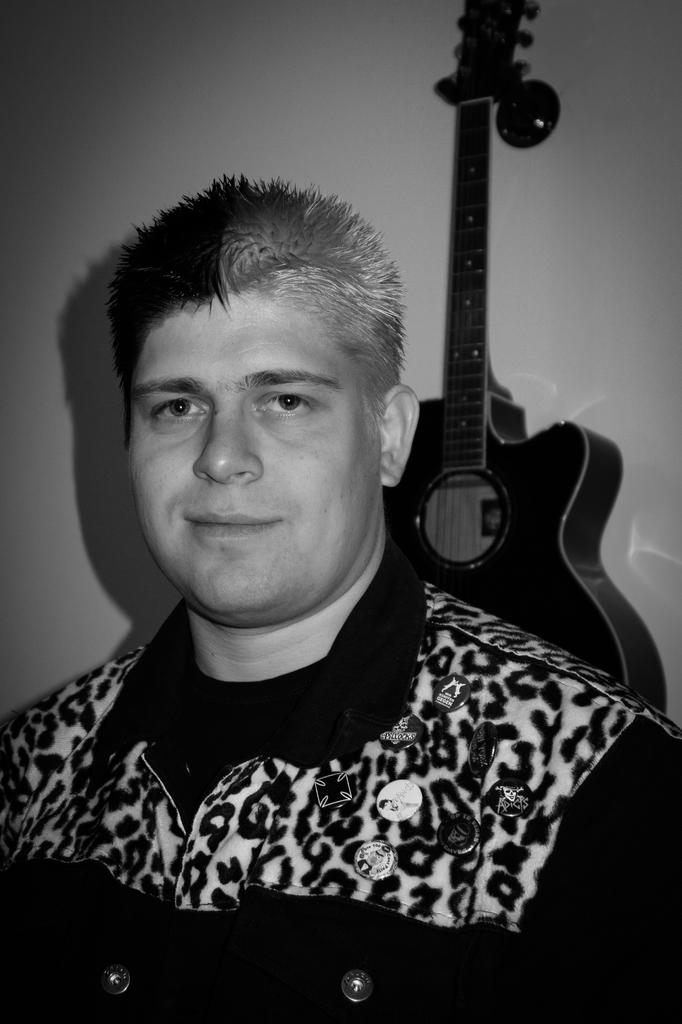What is present in the image? There is a man and a guitar on the right side of the image. Can you describe the man in the image? The facts provided do not give any specific details about the man's appearance or actions. What instrument is visible in the image? There is a guitar on the right side of the image. What type of thunder can be heard in the image? There is no mention of thunder or any sound in the image, so it cannot be heard. 